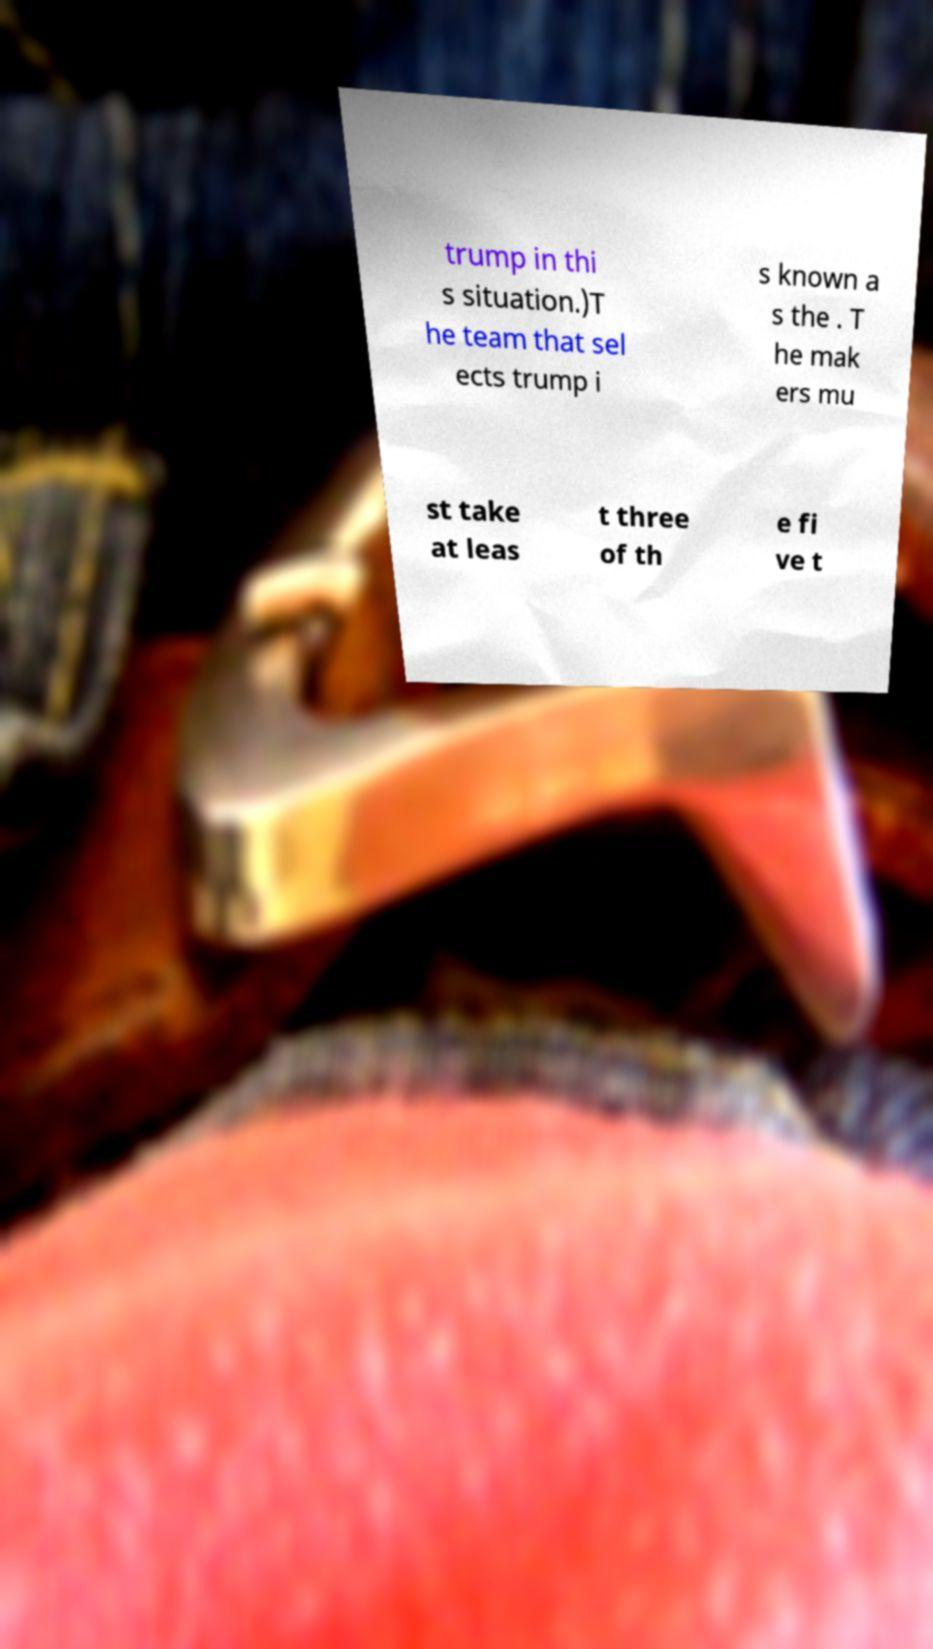What messages or text are displayed in this image? I need them in a readable, typed format. trump in thi s situation.)T he team that sel ects trump i s known a s the . T he mak ers mu st take at leas t three of th e fi ve t 